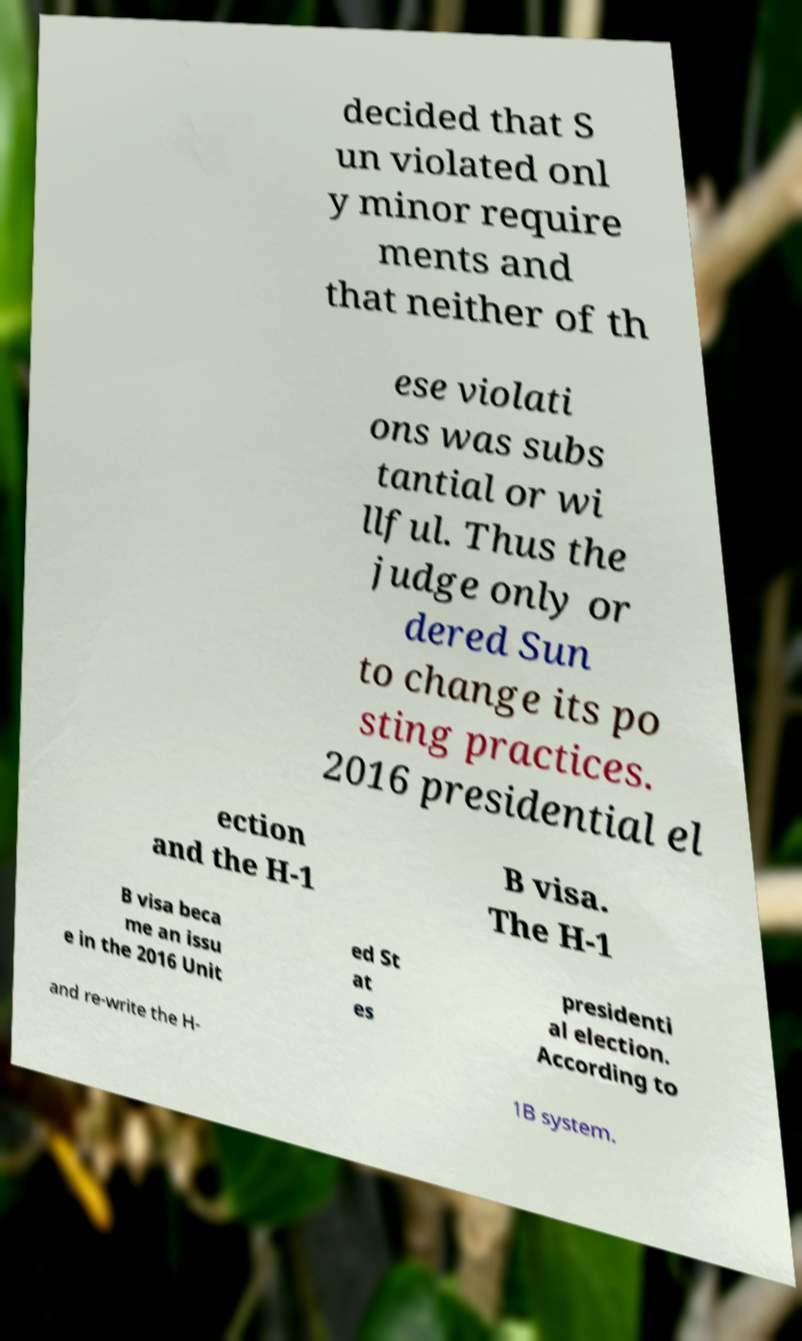Can you accurately transcribe the text from the provided image for me? decided that S un violated onl y minor require ments and that neither of th ese violati ons was subs tantial or wi llful. Thus the judge only or dered Sun to change its po sting practices. 2016 presidential el ection and the H-1 B visa. The H-1 B visa beca me an issu e in the 2016 Unit ed St at es presidenti al election. According to and re-write the H- 1B system. 